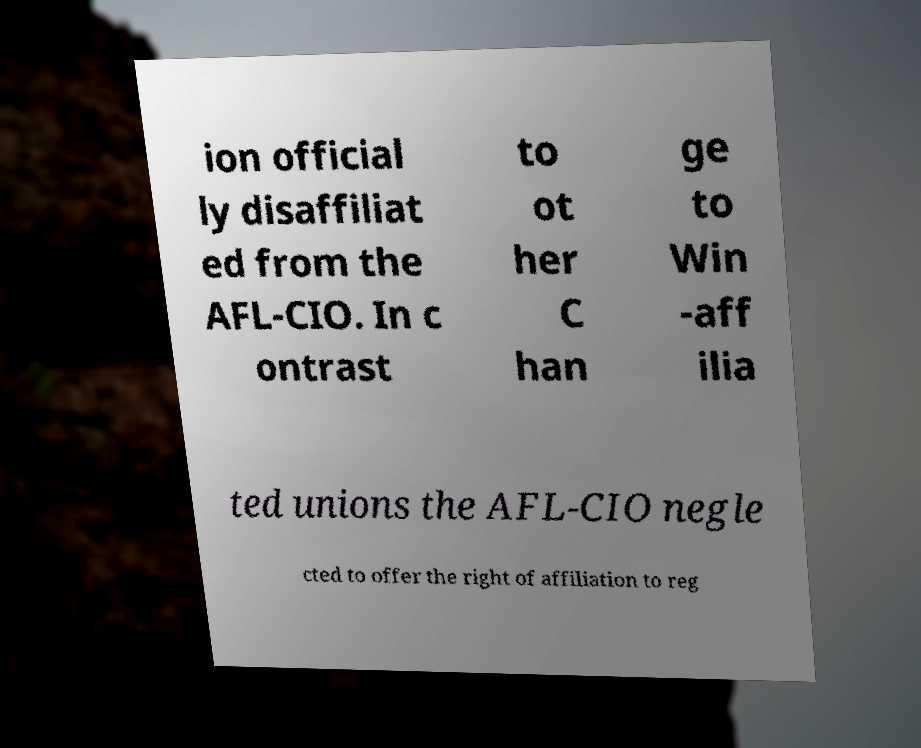For documentation purposes, I need the text within this image transcribed. Could you provide that? ion official ly disaffiliat ed from the AFL-CIO. In c ontrast to ot her C han ge to Win -aff ilia ted unions the AFL-CIO negle cted to offer the right of affiliation to reg 